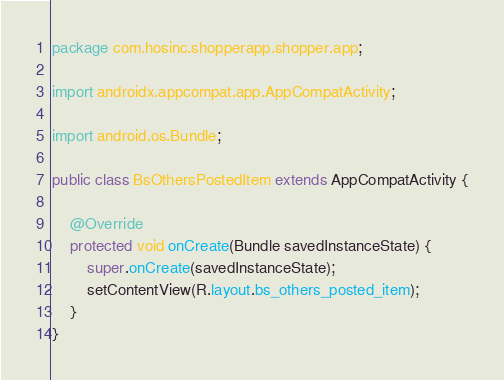Convert code to text. <code><loc_0><loc_0><loc_500><loc_500><_Java_>package com.hosinc.shopperapp.shopper.app;

import androidx.appcompat.app.AppCompatActivity;

import android.os.Bundle;

public class BsOthersPostedItem extends AppCompatActivity {

    @Override
    protected void onCreate(Bundle savedInstanceState) {
        super.onCreate(savedInstanceState);
        setContentView(R.layout.bs_others_posted_item);
    }
}</code> 